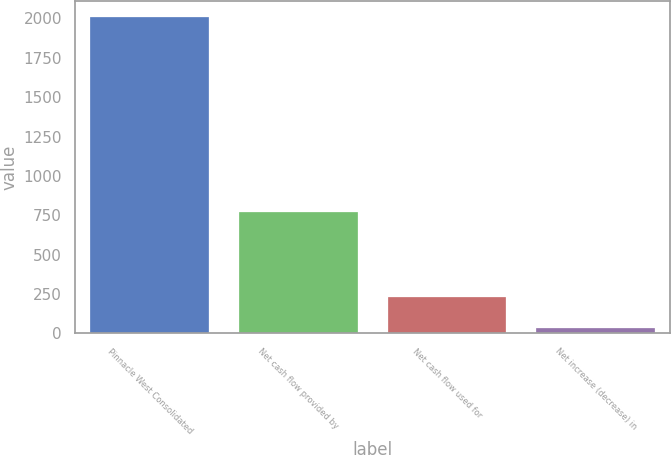<chart> <loc_0><loc_0><loc_500><loc_500><bar_chart><fcel>Pinnacle West Consolidated<fcel>Net cash flow provided by<fcel>Net cash flow used for<fcel>Net increase (decrease) in<nl><fcel>2010<fcel>773.5<fcel>232.5<fcel>35<nl></chart> 